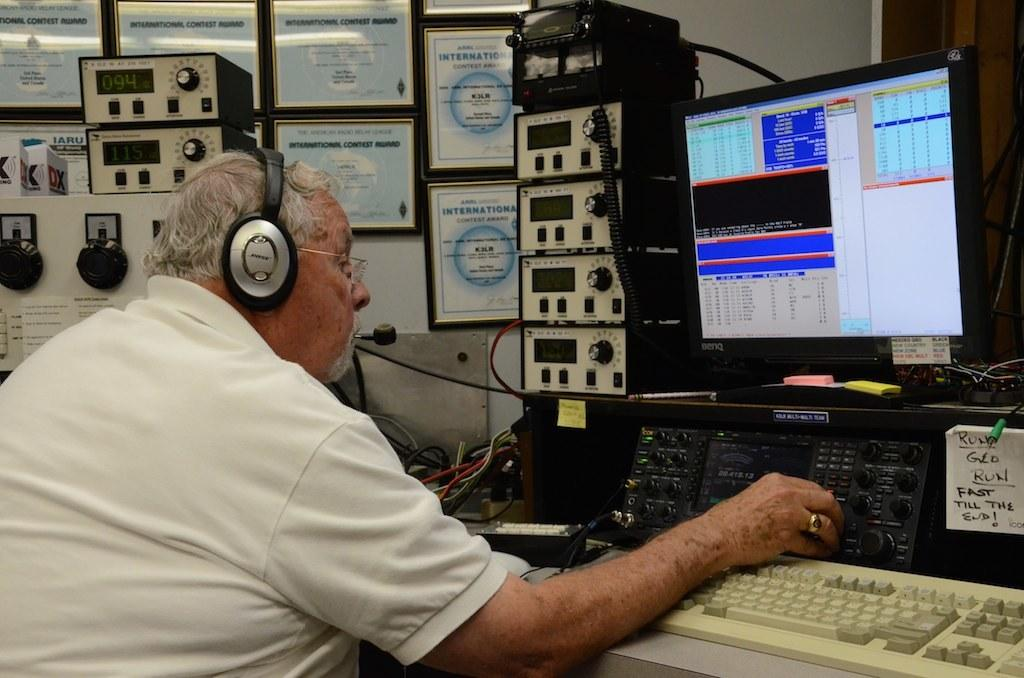<image>
Relay a brief, clear account of the picture shown. A man sitting in front of a computer with a note that reads, "Run Geo Run, Fast Till the End!" 